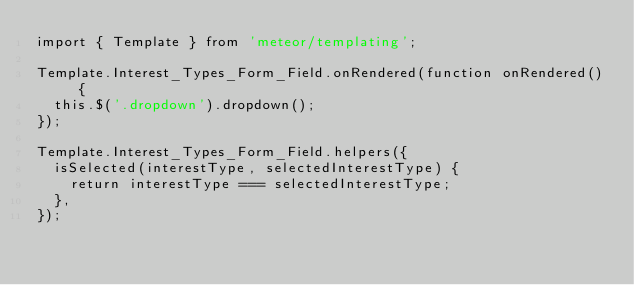Convert code to text. <code><loc_0><loc_0><loc_500><loc_500><_JavaScript_>import { Template } from 'meteor/templating';

Template.Interest_Types_Form_Field.onRendered(function onRendered() {
  this.$('.dropdown').dropdown();
});

Template.Interest_Types_Form_Field.helpers({
  isSelected(interestType, selectedInterestType) {
    return interestType === selectedInterestType;
  },
});
</code> 